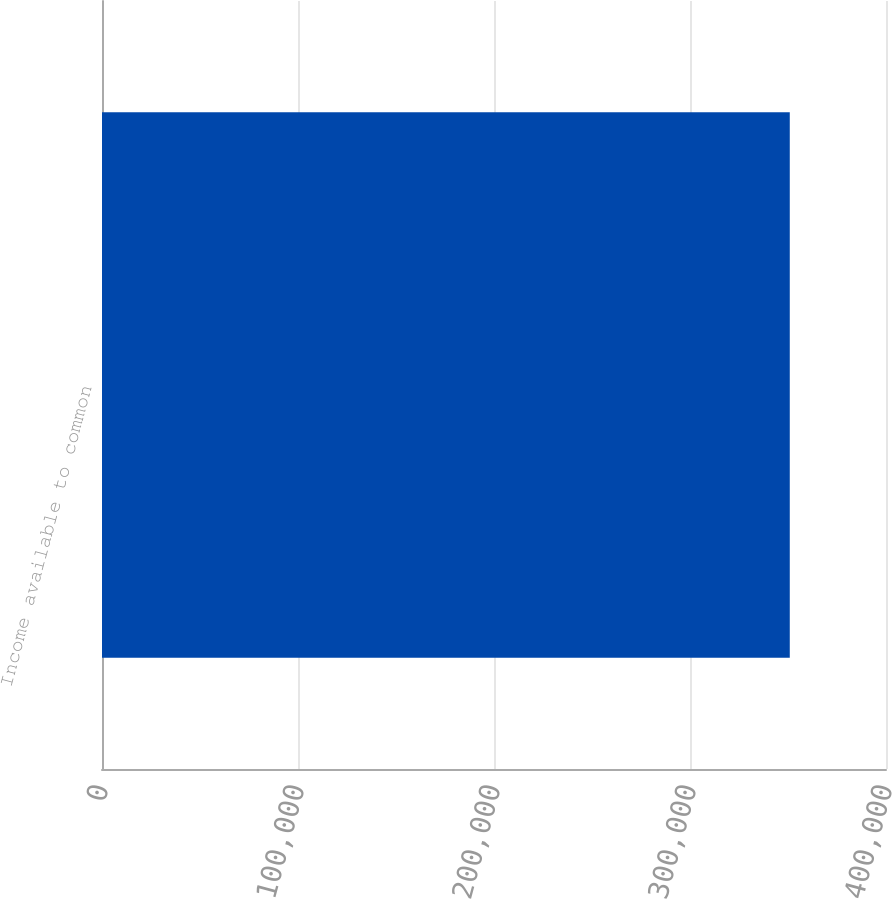<chart> <loc_0><loc_0><loc_500><loc_500><bar_chart><fcel>Income available to common<nl><fcel>350908<nl></chart> 